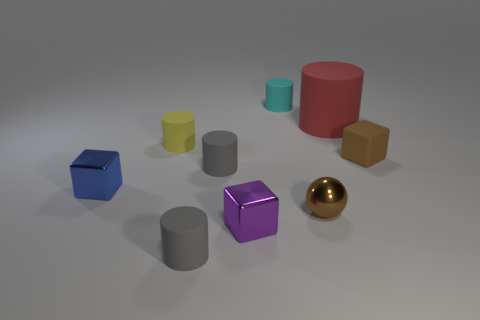Subtract all metallic blocks. How many blocks are left? 1 Add 1 small red things. How many objects exist? 10 Subtract all blue blocks. How many blocks are left? 2 Subtract 1 balls. How many balls are left? 0 Subtract all blue cylinders. How many blue blocks are left? 1 Add 5 large red rubber cylinders. How many large red rubber cylinders exist? 6 Subtract 0 brown cylinders. How many objects are left? 9 Subtract all cubes. How many objects are left? 6 Subtract all purple balls. Subtract all red cylinders. How many balls are left? 1 Subtract all tiny shiny balls. Subtract all cylinders. How many objects are left? 3 